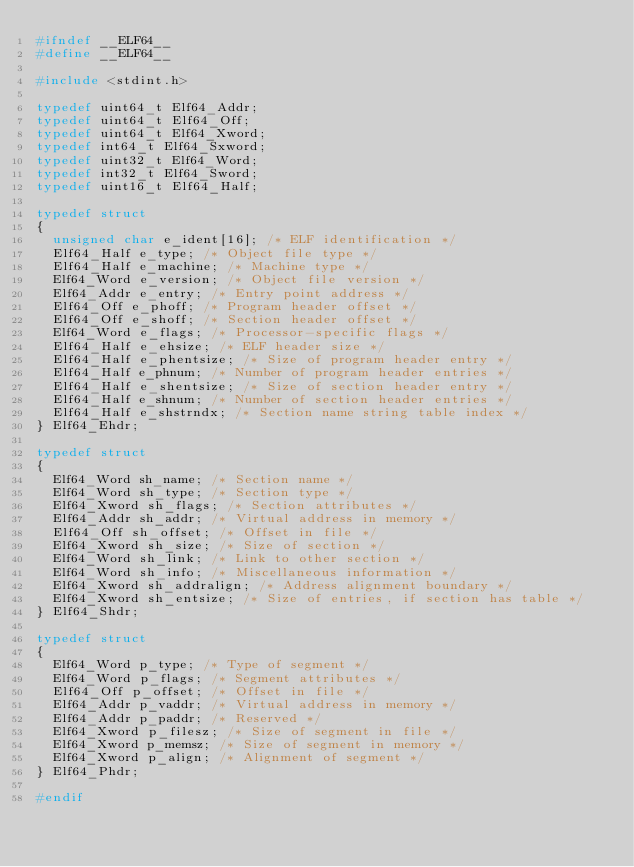Convert code to text. <code><loc_0><loc_0><loc_500><loc_500><_C_>#ifndef __ELF64__
#define __ELF64__

#include <stdint.h>

typedef uint64_t Elf64_Addr;
typedef uint64_t Elf64_Off;
typedef uint64_t Elf64_Xword;
typedef int64_t Elf64_Sxword;
typedef uint32_t Elf64_Word;
typedef int32_t Elf64_Sword;
typedef uint16_t Elf64_Half;

typedef struct
{
	unsigned char e_ident[16]; /* ELF identification */
	Elf64_Half e_type; /* Object file type */
	Elf64_Half e_machine; /* Machine type */
	Elf64_Word e_version; /* Object file version */
	Elf64_Addr e_entry; /* Entry point address */
	Elf64_Off e_phoff; /* Program header offset */
	Elf64_Off e_shoff; /* Section header offset */
	Elf64_Word e_flags; /* Processor-specific flags */
	Elf64_Half e_ehsize; /* ELF header size */
	Elf64_Half e_phentsize; /* Size of program header entry */
	Elf64_Half e_phnum; /* Number of program header entries */
	Elf64_Half e_shentsize; /* Size of section header entry */
	Elf64_Half e_shnum; /* Number of section header entries */
	Elf64_Half e_shstrndx; /* Section name string table index */
} Elf64_Ehdr;

typedef struct
{
	Elf64_Word sh_name; /* Section name */
	Elf64_Word sh_type; /* Section type */
	Elf64_Xword sh_flags; /* Section attributes */
	Elf64_Addr sh_addr; /* Virtual address in memory */
	Elf64_Off sh_offset; /* Offset in file */
	Elf64_Xword sh_size; /* Size of section */
	Elf64_Word sh_link; /* Link to other section */
	Elf64_Word sh_info; /* Miscellaneous information */
	Elf64_Xword sh_addralign; /* Address alignment boundary */
	Elf64_Xword sh_entsize; /* Size of entries, if section has table */
} Elf64_Shdr;

typedef struct
{
	Elf64_Word p_type; /* Type of segment */
	Elf64_Word p_flags; /* Segment attributes */
	Elf64_Off p_offset; /* Offset in file */
	Elf64_Addr p_vaddr; /* Virtual address in memory */
	Elf64_Addr p_paddr; /* Reserved */
	Elf64_Xword p_filesz; /* Size of segment in file */
	Elf64_Xword p_memsz; /* Size of segment in memory */
	Elf64_Xword p_align; /* Alignment of segment */
} Elf64_Phdr;

#endif</code> 